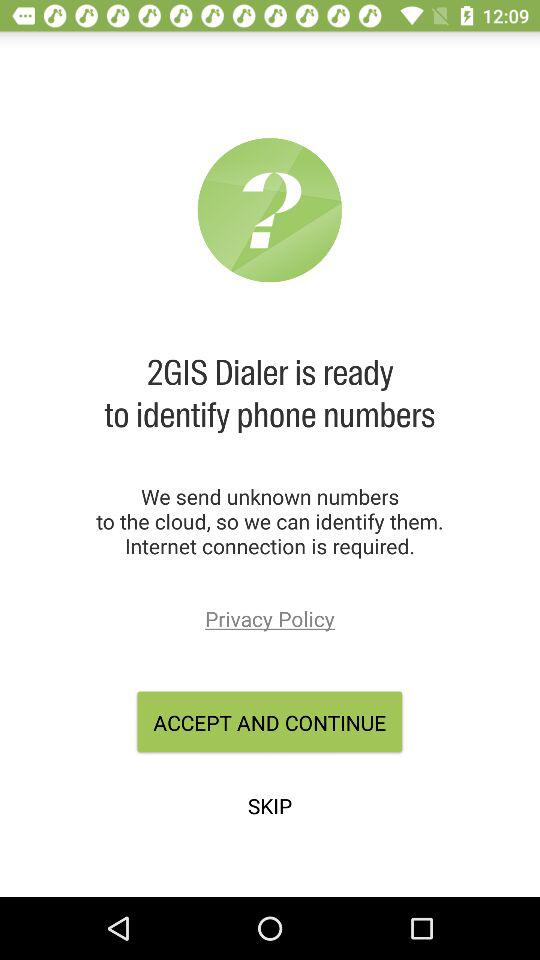Who's up for identifying phone numbers? The app for identifying phone numbers is "2GIS Dialer". 